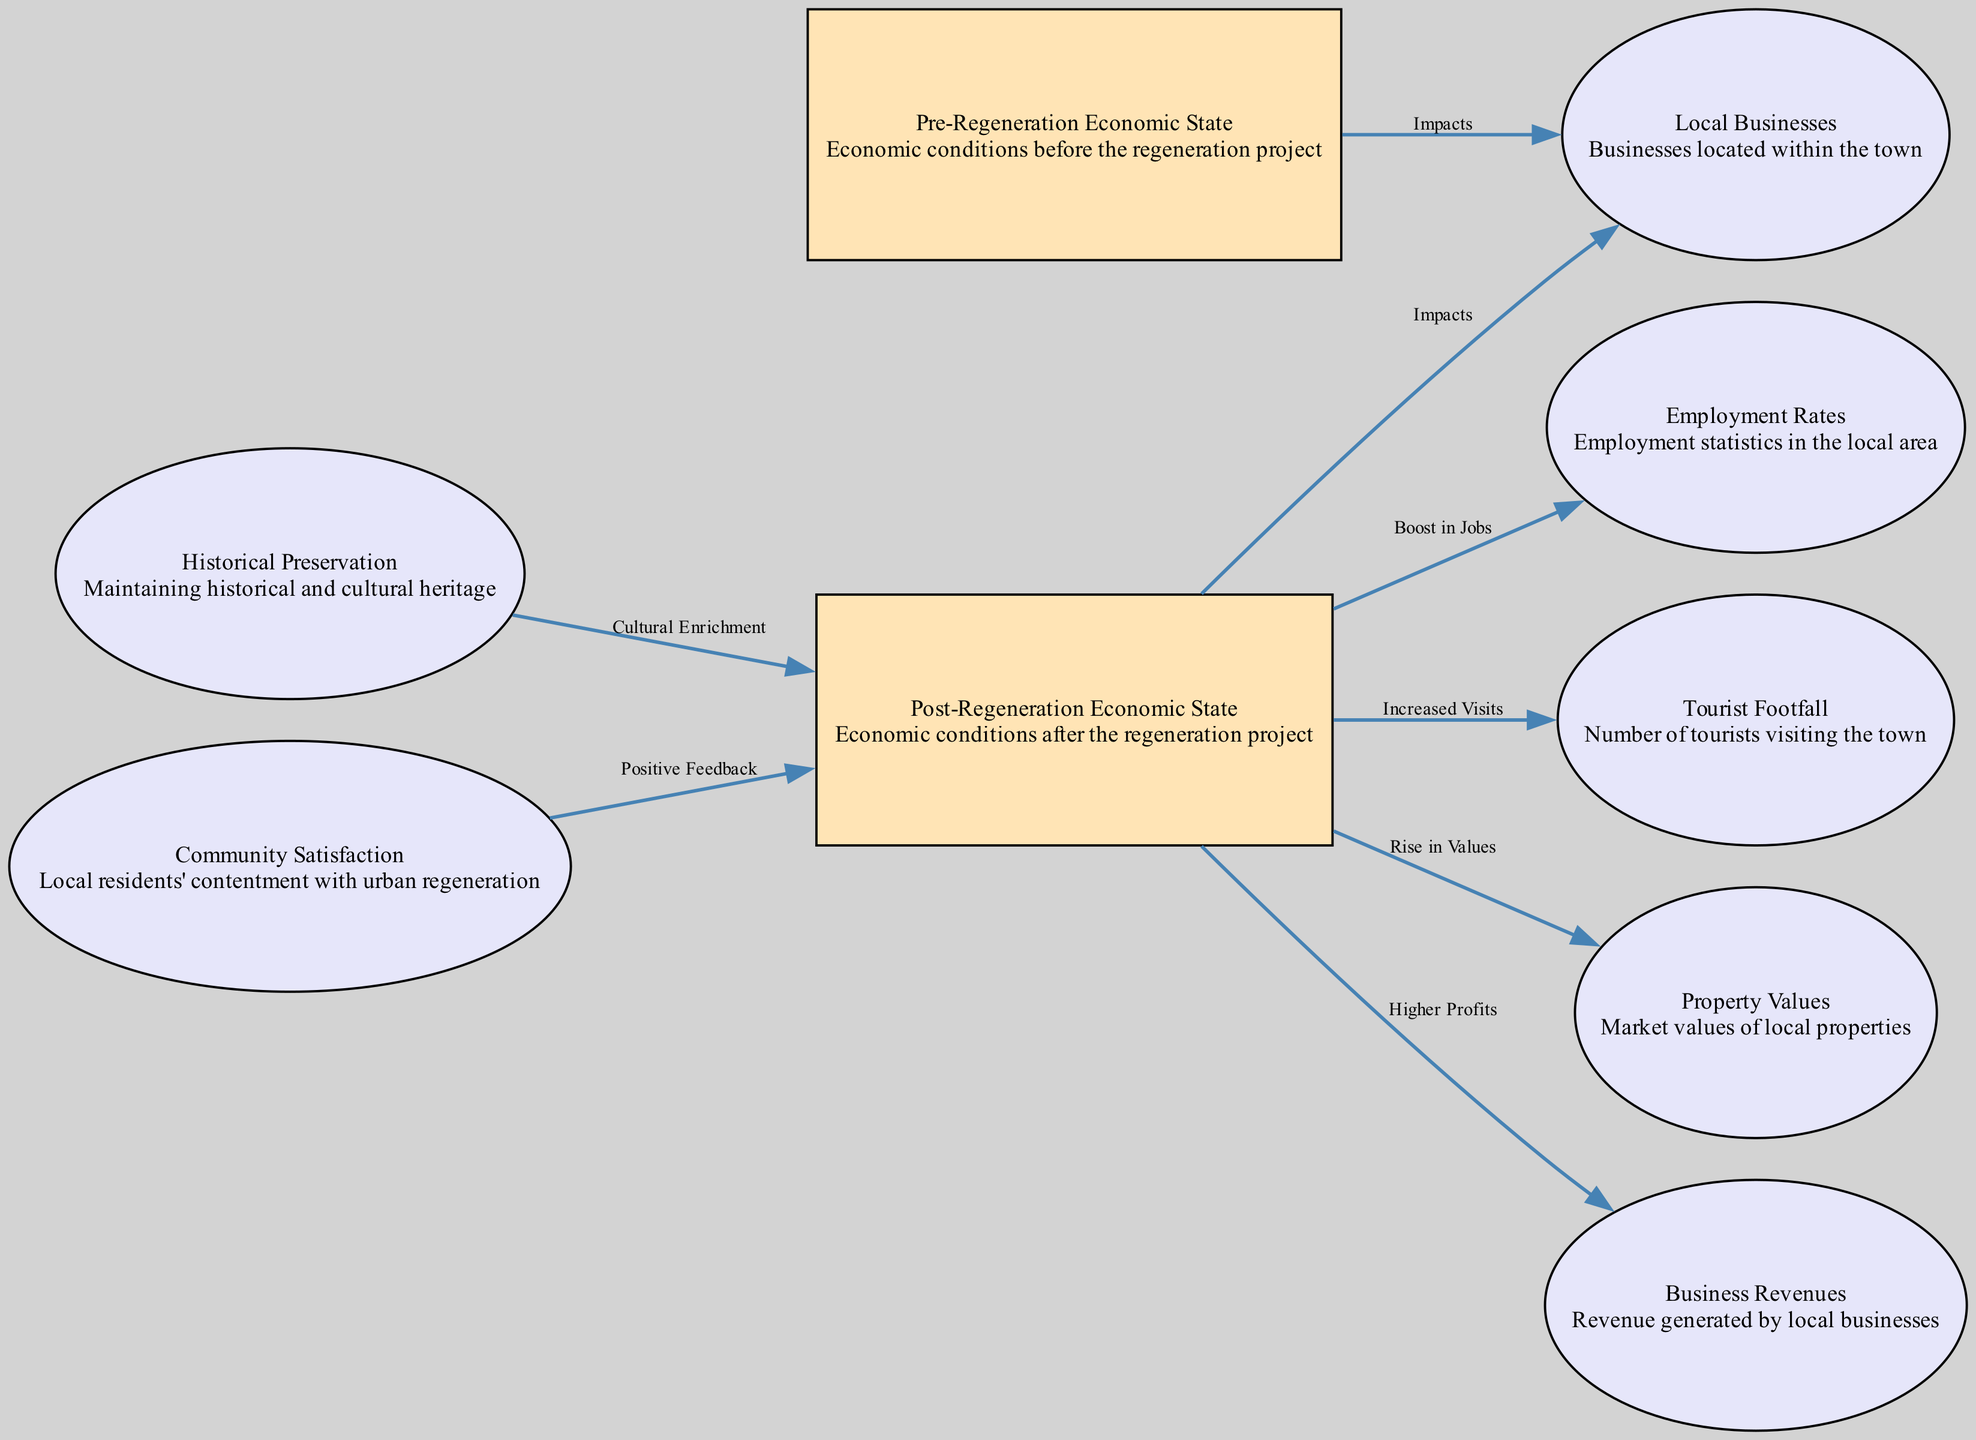What are the two economic states depicted in the diagram? The diagram showcases "Pre-Regeneration Economic State" and "Post-Regeneration Economic State" as its two main nodes, representing the economic conditions before and after the urban regeneration project.
Answer: Pre-Regeneration Economic State, Post-Regeneration Economic State How many nodes are present in the diagram? By counting the nodes listed in the diagram, we see there are nine nodes in total, which include both economic states, local businesses, employment rates, tourist footfall, property values, business revenues, historical preservation, and community satisfaction.
Answer: 9 What is the relationship between "Post-Regeneration Economic State" and "Local Businesses"? The diagram indicates a direct link between the "Post-Regeneration Economic State" and "Local Businesses," showing that there are impacts on local businesses resulting from changes in the post-regeneration economic conditions.
Answer: Impacts What impact does regeneration have on "Employment Rates"? The diagram states that there is a direct connection from the "Post-Regeneration Economic State" to "Employment Rates," labelled "Boost in Jobs," which signifies that regeneration leads to increased employment opportunities in the area.
Answer: Boost in Jobs What effect does historical preservation have on the economic state? According to the diagram, "Historical Preservation" contributes positively to the "Post-Regeneration Economic State," labelled "Cultural Enrichment," suggesting that maintaining the town's historical essence can enhance the economic scenario after regeneration.
Answer: Cultural Enrichment How does community satisfaction relate to post-regeneration? The diagram shows that "Community Satisfaction" has a connection to the "Post-Regeneration Economic State," labelled "Positive Feedback," indicating that increased community satisfaction translates into positive perceptions of the economic conditions post-regeneration.
Answer: Positive Feedback What rise is correlated to property values after regeneration? The diagram establishes a link from the "Post-Regeneration Economic State" to "Property Values," illustrated as "Rise in Values," meaning that economic improvements post-regeneration generally coincide with increased property market values.
Answer: Rise in Values What factor influences "Business Revenues" after regeneration? "Business Revenues" is directly impacted by the "Post-Regeneration Economic State," with the diagram indicating "Higher Profits" as the effect of regeneration efforts, showcasing economic growth translating into increased revenues for local businesses.
Answer: Higher Profits 